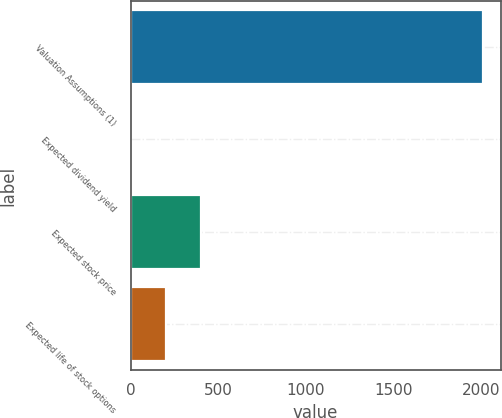Convert chart. <chart><loc_0><loc_0><loc_500><loc_500><bar_chart><fcel>Valuation Assumptions (1)<fcel>Expected dividend yield<fcel>Expected stock price<fcel>Expected life of stock options<nl><fcel>2009<fcel>1.6<fcel>403.08<fcel>202.34<nl></chart> 